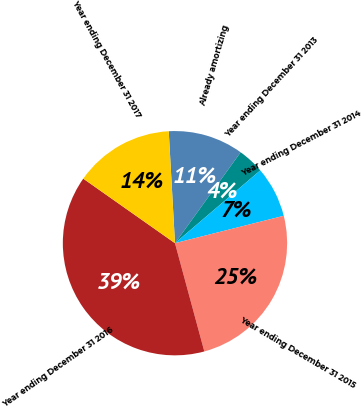Convert chart. <chart><loc_0><loc_0><loc_500><loc_500><pie_chart><fcel>Already amortizing<fcel>Year ending December 31 2013<fcel>Year ending December 31 2014<fcel>Year ending December 31 2015<fcel>Year ending December 31 2016<fcel>Year ending December 31 2017<nl><fcel>10.84%<fcel>3.8%<fcel>7.32%<fcel>24.71%<fcel>38.97%<fcel>14.35%<nl></chart> 